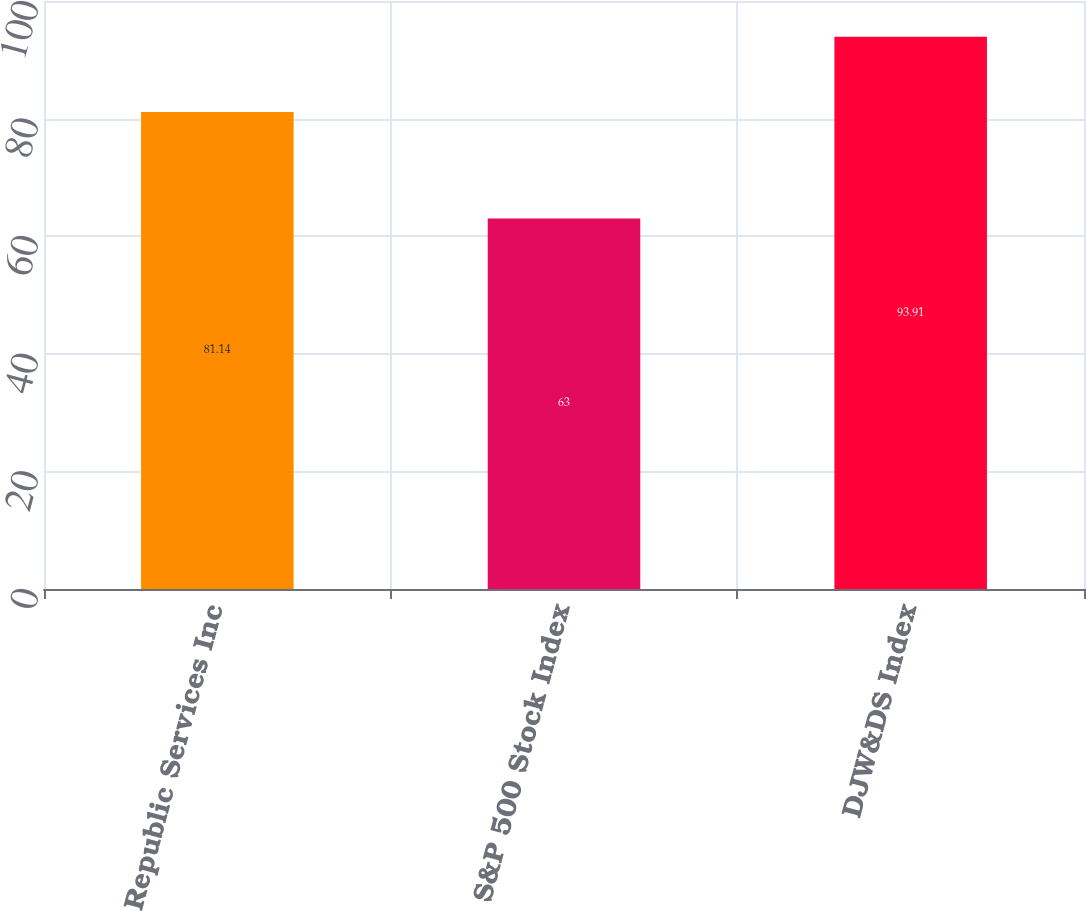<chart> <loc_0><loc_0><loc_500><loc_500><bar_chart><fcel>Republic Services Inc<fcel>S&P 500 Stock Index<fcel>DJW&DS Index<nl><fcel>81.14<fcel>63<fcel>93.91<nl></chart> 